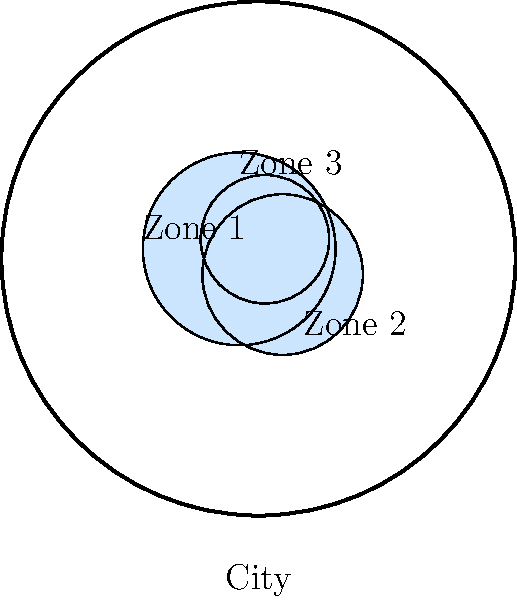In the diagram above, three economic opportunity zones are depicted within a circular city boundary. If you were tasked with creating a visual narrative about the economic landscape of this city, which topological property of these zones would be most relevant to highlight the potential for interconnected growth and development? To answer this question, let's consider the topological properties of the economic opportunity zones:

1. Shape: All zones are circular, which doesn't provide much distinctive information.

2. Size: The zones vary in size, but this alone doesn't signify interconnectedness.

3. Position: The zones are distributed across the city, which is important but not the key factor for this question.

4. Boundaries: This is the most relevant property for interconnected growth.

5. Connectivity: Examining the boundaries reveals that the zones do not intersect or touch each other.

The lack of intersection or touching between the zones is the most significant topological property in this context. It suggests that:

a) There are gaps between the zones, potentially representing areas of missed economic opportunities.
b) The zones are currently isolated, which may limit the spread of economic benefits.
c) There's potential for expanding the zones or creating corridors between them to foster interconnected growth.

For a videographer focusing on visually rich human interest stories complementing economic narratives, this property offers the most compelling visual and narrative opportunities. It allows for stories about:

- The experiences of people living just outside these zones
- The potential for bridging these gaps to create a more inclusive economic landscape
- The challenges and opportunities in connecting these isolated areas of opportunity

Therefore, the most relevant topological property to highlight is the non-intersection of the zone boundaries.
Answer: Non-intersection of zone boundaries 